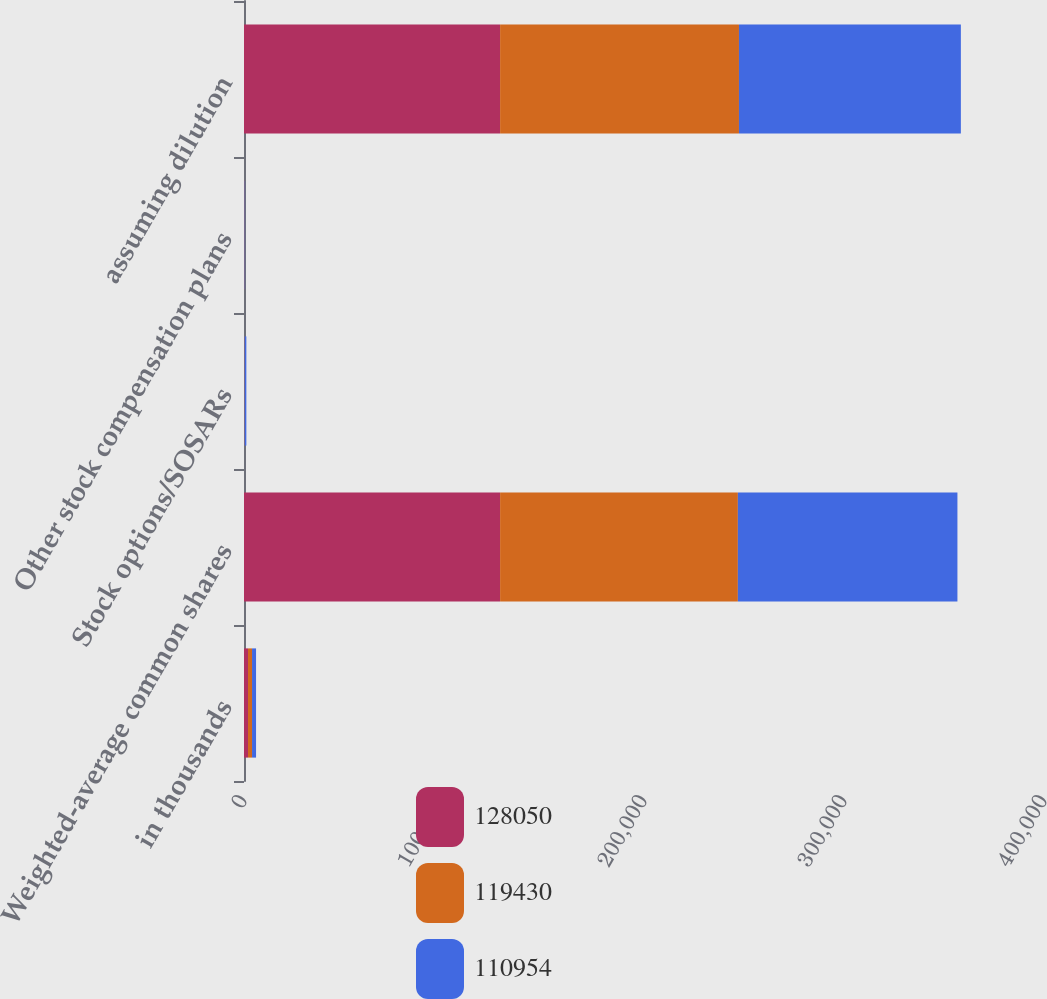<chart> <loc_0><loc_0><loc_500><loc_500><stacked_bar_chart><ecel><fcel>in thousands<fcel>Weighted-average common shares<fcel>Stock options/SOSARs<fcel>Other stock compensation plans<fcel>assuming dilution<nl><fcel>128050<fcel>2010<fcel>128050<fcel>0<fcel>0<fcel>128050<nl><fcel>119430<fcel>2009<fcel>118891<fcel>269<fcel>270<fcel>119430<nl><fcel>110954<fcel>2008<fcel>109774<fcel>905<fcel>275<fcel>110954<nl></chart> 